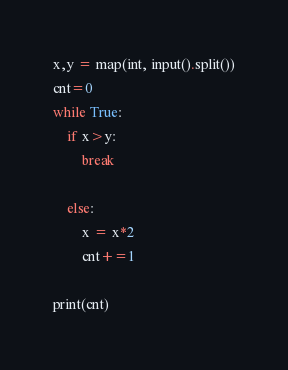Convert code to text. <code><loc_0><loc_0><loc_500><loc_500><_Python_>x,y = map(int, input().split())
cnt=0
while True:
    if x>y:
        break

    else:
        x = x*2
        cnt+=1

print(cnt)    
</code> 